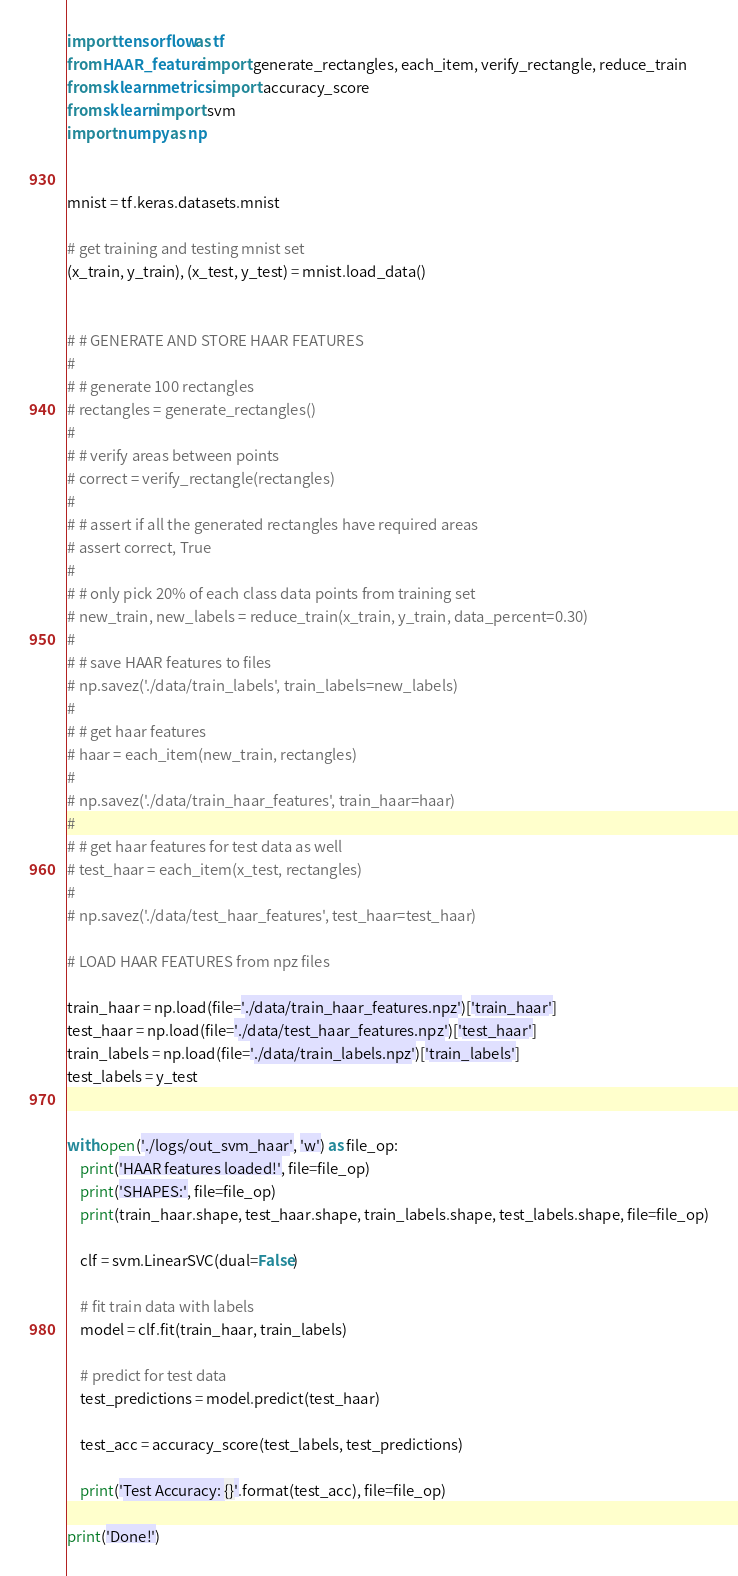Convert code to text. <code><loc_0><loc_0><loc_500><loc_500><_Python_>import tensorflow as tf
from HAAR_feature import generate_rectangles, each_item, verify_rectangle, reduce_train
from sklearn.metrics import accuracy_score
from sklearn import svm
import numpy as np


mnist = tf.keras.datasets.mnist

# get training and testing mnist set
(x_train, y_train), (x_test, y_test) = mnist.load_data()


# # GENERATE AND STORE HAAR FEATURES
#
# # generate 100 rectangles
# rectangles = generate_rectangles()
#
# # verify areas between points
# correct = verify_rectangle(rectangles)
#
# # assert if all the generated rectangles have required areas
# assert correct, True
#
# # only pick 20% of each class data points from training set
# new_train, new_labels = reduce_train(x_train, y_train, data_percent=0.30)
#
# # save HAAR features to files
# np.savez('./data/train_labels', train_labels=new_labels)
#
# # get haar features
# haar = each_item(new_train, rectangles)
#
# np.savez('./data/train_haar_features', train_haar=haar)
#
# # get haar features for test data as well
# test_haar = each_item(x_test, rectangles)
#
# np.savez('./data/test_haar_features', test_haar=test_haar)

# LOAD HAAR FEATURES from npz files

train_haar = np.load(file='./data/train_haar_features.npz')['train_haar']
test_haar = np.load(file='./data/test_haar_features.npz')['test_haar']
train_labels = np.load(file='./data/train_labels.npz')['train_labels']
test_labels = y_test


with open('./logs/out_svm_haar', 'w') as file_op:
    print('HAAR features loaded!', file=file_op)
    print('SHAPES:', file=file_op)
    print(train_haar.shape, test_haar.shape, train_labels.shape, test_labels.shape, file=file_op)

    clf = svm.LinearSVC(dual=False)

    # fit train data with labels
    model = clf.fit(train_haar, train_labels)

    # predict for test data
    test_predictions = model.predict(test_haar)

    test_acc = accuracy_score(test_labels, test_predictions)

    print('Test Accuracy: {}'.format(test_acc), file=file_op)

print('Done!')
</code> 